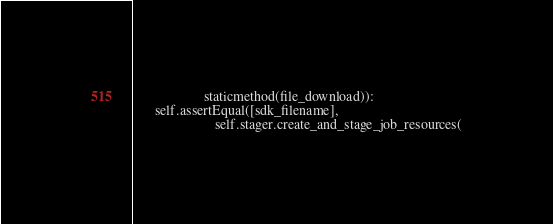<code> <loc_0><loc_0><loc_500><loc_500><_Python_>                    staticmethod(file_download)):
      self.assertEqual([sdk_filename],
                       self.stager.create_and_stage_job_resources(</code> 